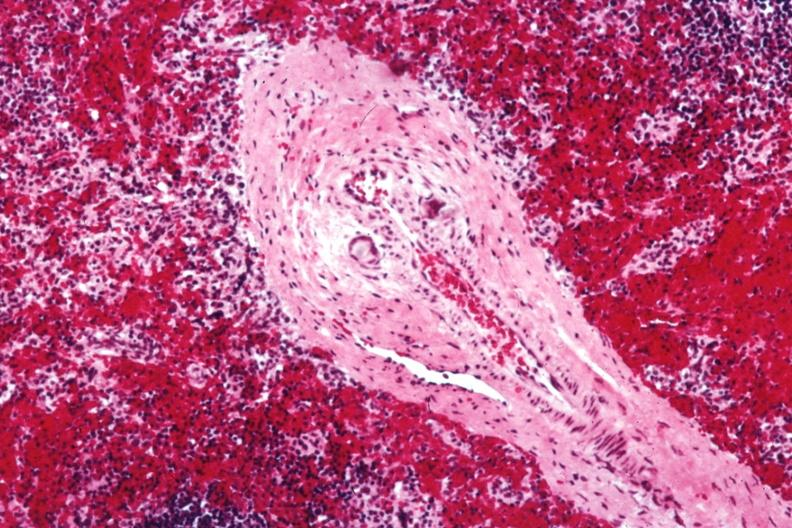what containing crystalline material postoperative cardiac surgery thought to be silicon?
Answer the question using a single word or phrase. Giant cells in wall 